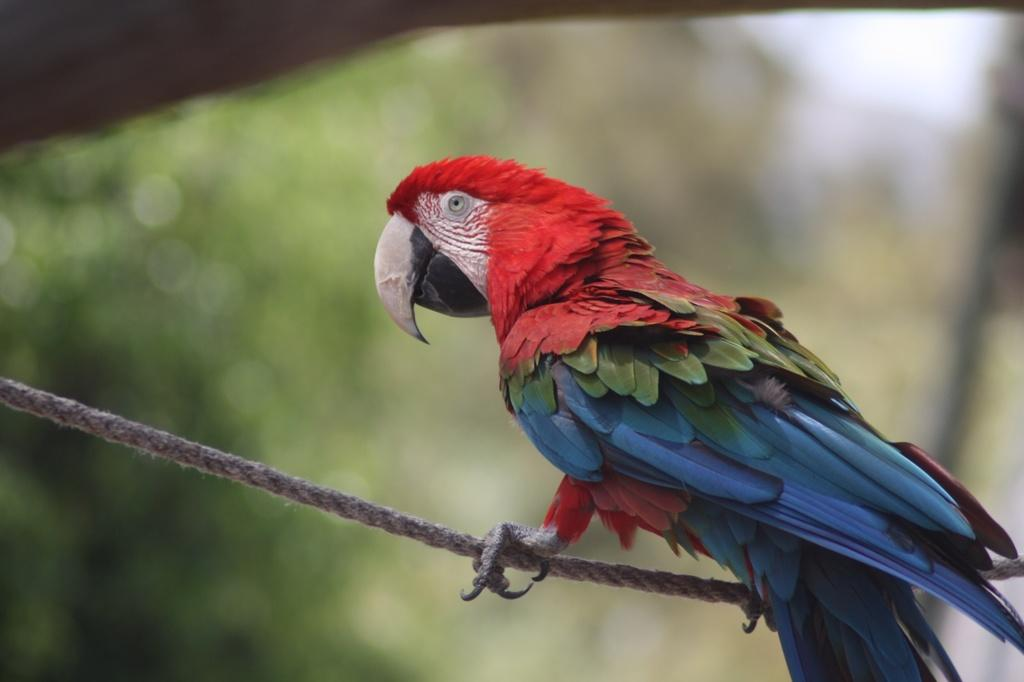What type of animal is in the image? There is a parrot in the image. What is the parrot standing on? The parrot is standing on a rope. What colors can be seen on the parrot? The parrot has red, blue, and green colors. What type of gun is the parrot holding in the image? There is no gun present in the image; the parrot is standing on a rope and has no visible objects in its possession. 